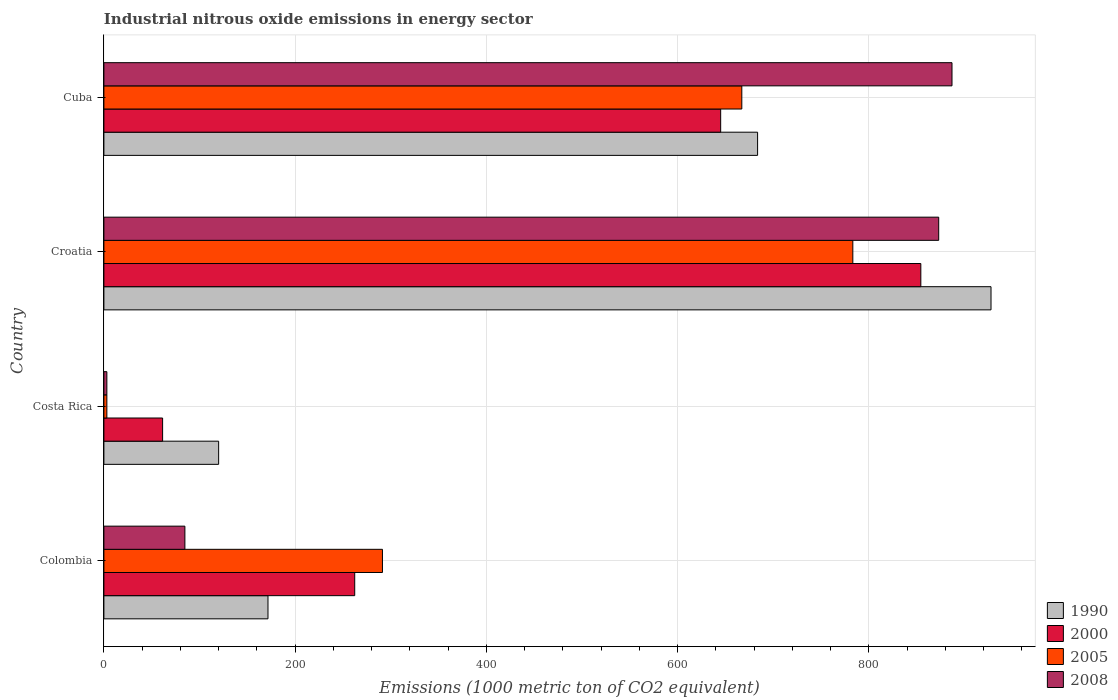How many different coloured bars are there?
Your answer should be very brief. 4. How many groups of bars are there?
Make the answer very short. 4. Are the number of bars on each tick of the Y-axis equal?
Offer a very short reply. Yes. How many bars are there on the 3rd tick from the top?
Provide a succinct answer. 4. How many bars are there on the 4th tick from the bottom?
Your answer should be compact. 4. What is the label of the 1st group of bars from the top?
Your answer should be very brief. Cuba. In how many cases, is the number of bars for a given country not equal to the number of legend labels?
Provide a short and direct response. 0. What is the amount of industrial nitrous oxide emitted in 1990 in Croatia?
Offer a very short reply. 927.7. Across all countries, what is the maximum amount of industrial nitrous oxide emitted in 2005?
Your answer should be compact. 783.2. Across all countries, what is the minimum amount of industrial nitrous oxide emitted in 2000?
Offer a very short reply. 61.4. In which country was the amount of industrial nitrous oxide emitted in 2000 maximum?
Give a very brief answer. Croatia. In which country was the amount of industrial nitrous oxide emitted in 1990 minimum?
Your answer should be very brief. Costa Rica. What is the total amount of industrial nitrous oxide emitted in 2005 in the graph?
Provide a short and direct response. 1744.7. What is the difference between the amount of industrial nitrous oxide emitted in 2008 in Croatia and that in Cuba?
Provide a succinct answer. -13.9. What is the difference between the amount of industrial nitrous oxide emitted in 2005 in Colombia and the amount of industrial nitrous oxide emitted in 2000 in Costa Rica?
Offer a terse response. 229.9. What is the average amount of industrial nitrous oxide emitted in 1990 per country?
Offer a terse response. 475.73. What is the difference between the amount of industrial nitrous oxide emitted in 2000 and amount of industrial nitrous oxide emitted in 2008 in Cuba?
Your answer should be compact. -241.9. In how many countries, is the amount of industrial nitrous oxide emitted in 2005 greater than 800 1000 metric ton?
Keep it short and to the point. 0. What is the ratio of the amount of industrial nitrous oxide emitted in 2000 in Croatia to that in Cuba?
Make the answer very short. 1.32. What is the difference between the highest and the second highest amount of industrial nitrous oxide emitted in 1990?
Offer a very short reply. 244.1. What is the difference between the highest and the lowest amount of industrial nitrous oxide emitted in 2000?
Provide a succinct answer. 792.9. Is the sum of the amount of industrial nitrous oxide emitted in 1990 in Colombia and Croatia greater than the maximum amount of industrial nitrous oxide emitted in 2008 across all countries?
Offer a terse response. Yes. How many bars are there?
Make the answer very short. 16. How many countries are there in the graph?
Keep it short and to the point. 4. Where does the legend appear in the graph?
Offer a terse response. Bottom right. How are the legend labels stacked?
Provide a succinct answer. Vertical. What is the title of the graph?
Your response must be concise. Industrial nitrous oxide emissions in energy sector. What is the label or title of the X-axis?
Your response must be concise. Emissions (1000 metric ton of CO2 equivalent). What is the label or title of the Y-axis?
Offer a terse response. Country. What is the Emissions (1000 metric ton of CO2 equivalent) of 1990 in Colombia?
Ensure brevity in your answer.  171.6. What is the Emissions (1000 metric ton of CO2 equivalent) of 2000 in Colombia?
Offer a very short reply. 262.3. What is the Emissions (1000 metric ton of CO2 equivalent) of 2005 in Colombia?
Make the answer very short. 291.3. What is the Emissions (1000 metric ton of CO2 equivalent) of 2008 in Colombia?
Give a very brief answer. 84.7. What is the Emissions (1000 metric ton of CO2 equivalent) of 1990 in Costa Rica?
Ensure brevity in your answer.  120. What is the Emissions (1000 metric ton of CO2 equivalent) in 2000 in Costa Rica?
Keep it short and to the point. 61.4. What is the Emissions (1000 metric ton of CO2 equivalent) of 2005 in Costa Rica?
Offer a terse response. 3.1. What is the Emissions (1000 metric ton of CO2 equivalent) in 2008 in Costa Rica?
Your answer should be very brief. 3.1. What is the Emissions (1000 metric ton of CO2 equivalent) in 1990 in Croatia?
Offer a terse response. 927.7. What is the Emissions (1000 metric ton of CO2 equivalent) of 2000 in Croatia?
Your response must be concise. 854.3. What is the Emissions (1000 metric ton of CO2 equivalent) of 2005 in Croatia?
Offer a very short reply. 783.2. What is the Emissions (1000 metric ton of CO2 equivalent) in 2008 in Croatia?
Make the answer very short. 873. What is the Emissions (1000 metric ton of CO2 equivalent) in 1990 in Cuba?
Provide a short and direct response. 683.6. What is the Emissions (1000 metric ton of CO2 equivalent) of 2000 in Cuba?
Ensure brevity in your answer.  645. What is the Emissions (1000 metric ton of CO2 equivalent) of 2005 in Cuba?
Make the answer very short. 667.1. What is the Emissions (1000 metric ton of CO2 equivalent) of 2008 in Cuba?
Keep it short and to the point. 886.9. Across all countries, what is the maximum Emissions (1000 metric ton of CO2 equivalent) of 1990?
Make the answer very short. 927.7. Across all countries, what is the maximum Emissions (1000 metric ton of CO2 equivalent) in 2000?
Ensure brevity in your answer.  854.3. Across all countries, what is the maximum Emissions (1000 metric ton of CO2 equivalent) in 2005?
Give a very brief answer. 783.2. Across all countries, what is the maximum Emissions (1000 metric ton of CO2 equivalent) of 2008?
Give a very brief answer. 886.9. Across all countries, what is the minimum Emissions (1000 metric ton of CO2 equivalent) of 1990?
Your response must be concise. 120. Across all countries, what is the minimum Emissions (1000 metric ton of CO2 equivalent) of 2000?
Provide a short and direct response. 61.4. Across all countries, what is the minimum Emissions (1000 metric ton of CO2 equivalent) of 2005?
Provide a succinct answer. 3.1. Across all countries, what is the minimum Emissions (1000 metric ton of CO2 equivalent) in 2008?
Your response must be concise. 3.1. What is the total Emissions (1000 metric ton of CO2 equivalent) in 1990 in the graph?
Offer a terse response. 1902.9. What is the total Emissions (1000 metric ton of CO2 equivalent) in 2000 in the graph?
Keep it short and to the point. 1823. What is the total Emissions (1000 metric ton of CO2 equivalent) in 2005 in the graph?
Your answer should be very brief. 1744.7. What is the total Emissions (1000 metric ton of CO2 equivalent) in 2008 in the graph?
Give a very brief answer. 1847.7. What is the difference between the Emissions (1000 metric ton of CO2 equivalent) in 1990 in Colombia and that in Costa Rica?
Make the answer very short. 51.6. What is the difference between the Emissions (1000 metric ton of CO2 equivalent) of 2000 in Colombia and that in Costa Rica?
Give a very brief answer. 200.9. What is the difference between the Emissions (1000 metric ton of CO2 equivalent) of 2005 in Colombia and that in Costa Rica?
Give a very brief answer. 288.2. What is the difference between the Emissions (1000 metric ton of CO2 equivalent) in 2008 in Colombia and that in Costa Rica?
Offer a terse response. 81.6. What is the difference between the Emissions (1000 metric ton of CO2 equivalent) in 1990 in Colombia and that in Croatia?
Offer a very short reply. -756.1. What is the difference between the Emissions (1000 metric ton of CO2 equivalent) in 2000 in Colombia and that in Croatia?
Offer a terse response. -592. What is the difference between the Emissions (1000 metric ton of CO2 equivalent) in 2005 in Colombia and that in Croatia?
Your answer should be compact. -491.9. What is the difference between the Emissions (1000 metric ton of CO2 equivalent) of 2008 in Colombia and that in Croatia?
Keep it short and to the point. -788.3. What is the difference between the Emissions (1000 metric ton of CO2 equivalent) in 1990 in Colombia and that in Cuba?
Keep it short and to the point. -512. What is the difference between the Emissions (1000 metric ton of CO2 equivalent) of 2000 in Colombia and that in Cuba?
Offer a terse response. -382.7. What is the difference between the Emissions (1000 metric ton of CO2 equivalent) of 2005 in Colombia and that in Cuba?
Ensure brevity in your answer.  -375.8. What is the difference between the Emissions (1000 metric ton of CO2 equivalent) of 2008 in Colombia and that in Cuba?
Ensure brevity in your answer.  -802.2. What is the difference between the Emissions (1000 metric ton of CO2 equivalent) in 1990 in Costa Rica and that in Croatia?
Your response must be concise. -807.7. What is the difference between the Emissions (1000 metric ton of CO2 equivalent) in 2000 in Costa Rica and that in Croatia?
Provide a short and direct response. -792.9. What is the difference between the Emissions (1000 metric ton of CO2 equivalent) in 2005 in Costa Rica and that in Croatia?
Provide a short and direct response. -780.1. What is the difference between the Emissions (1000 metric ton of CO2 equivalent) in 2008 in Costa Rica and that in Croatia?
Your answer should be compact. -869.9. What is the difference between the Emissions (1000 metric ton of CO2 equivalent) of 1990 in Costa Rica and that in Cuba?
Offer a very short reply. -563.6. What is the difference between the Emissions (1000 metric ton of CO2 equivalent) in 2000 in Costa Rica and that in Cuba?
Your answer should be compact. -583.6. What is the difference between the Emissions (1000 metric ton of CO2 equivalent) of 2005 in Costa Rica and that in Cuba?
Provide a short and direct response. -664. What is the difference between the Emissions (1000 metric ton of CO2 equivalent) of 2008 in Costa Rica and that in Cuba?
Provide a succinct answer. -883.8. What is the difference between the Emissions (1000 metric ton of CO2 equivalent) of 1990 in Croatia and that in Cuba?
Keep it short and to the point. 244.1. What is the difference between the Emissions (1000 metric ton of CO2 equivalent) in 2000 in Croatia and that in Cuba?
Your response must be concise. 209.3. What is the difference between the Emissions (1000 metric ton of CO2 equivalent) of 2005 in Croatia and that in Cuba?
Keep it short and to the point. 116.1. What is the difference between the Emissions (1000 metric ton of CO2 equivalent) in 1990 in Colombia and the Emissions (1000 metric ton of CO2 equivalent) in 2000 in Costa Rica?
Keep it short and to the point. 110.2. What is the difference between the Emissions (1000 metric ton of CO2 equivalent) in 1990 in Colombia and the Emissions (1000 metric ton of CO2 equivalent) in 2005 in Costa Rica?
Offer a very short reply. 168.5. What is the difference between the Emissions (1000 metric ton of CO2 equivalent) in 1990 in Colombia and the Emissions (1000 metric ton of CO2 equivalent) in 2008 in Costa Rica?
Your answer should be very brief. 168.5. What is the difference between the Emissions (1000 metric ton of CO2 equivalent) in 2000 in Colombia and the Emissions (1000 metric ton of CO2 equivalent) in 2005 in Costa Rica?
Make the answer very short. 259.2. What is the difference between the Emissions (1000 metric ton of CO2 equivalent) of 2000 in Colombia and the Emissions (1000 metric ton of CO2 equivalent) of 2008 in Costa Rica?
Your answer should be compact. 259.2. What is the difference between the Emissions (1000 metric ton of CO2 equivalent) of 2005 in Colombia and the Emissions (1000 metric ton of CO2 equivalent) of 2008 in Costa Rica?
Make the answer very short. 288.2. What is the difference between the Emissions (1000 metric ton of CO2 equivalent) of 1990 in Colombia and the Emissions (1000 metric ton of CO2 equivalent) of 2000 in Croatia?
Give a very brief answer. -682.7. What is the difference between the Emissions (1000 metric ton of CO2 equivalent) in 1990 in Colombia and the Emissions (1000 metric ton of CO2 equivalent) in 2005 in Croatia?
Provide a succinct answer. -611.6. What is the difference between the Emissions (1000 metric ton of CO2 equivalent) of 1990 in Colombia and the Emissions (1000 metric ton of CO2 equivalent) of 2008 in Croatia?
Your answer should be compact. -701.4. What is the difference between the Emissions (1000 metric ton of CO2 equivalent) in 2000 in Colombia and the Emissions (1000 metric ton of CO2 equivalent) in 2005 in Croatia?
Give a very brief answer. -520.9. What is the difference between the Emissions (1000 metric ton of CO2 equivalent) in 2000 in Colombia and the Emissions (1000 metric ton of CO2 equivalent) in 2008 in Croatia?
Your answer should be compact. -610.7. What is the difference between the Emissions (1000 metric ton of CO2 equivalent) in 2005 in Colombia and the Emissions (1000 metric ton of CO2 equivalent) in 2008 in Croatia?
Your response must be concise. -581.7. What is the difference between the Emissions (1000 metric ton of CO2 equivalent) of 1990 in Colombia and the Emissions (1000 metric ton of CO2 equivalent) of 2000 in Cuba?
Make the answer very short. -473.4. What is the difference between the Emissions (1000 metric ton of CO2 equivalent) in 1990 in Colombia and the Emissions (1000 metric ton of CO2 equivalent) in 2005 in Cuba?
Your answer should be compact. -495.5. What is the difference between the Emissions (1000 metric ton of CO2 equivalent) in 1990 in Colombia and the Emissions (1000 metric ton of CO2 equivalent) in 2008 in Cuba?
Provide a short and direct response. -715.3. What is the difference between the Emissions (1000 metric ton of CO2 equivalent) of 2000 in Colombia and the Emissions (1000 metric ton of CO2 equivalent) of 2005 in Cuba?
Provide a succinct answer. -404.8. What is the difference between the Emissions (1000 metric ton of CO2 equivalent) in 2000 in Colombia and the Emissions (1000 metric ton of CO2 equivalent) in 2008 in Cuba?
Ensure brevity in your answer.  -624.6. What is the difference between the Emissions (1000 metric ton of CO2 equivalent) in 2005 in Colombia and the Emissions (1000 metric ton of CO2 equivalent) in 2008 in Cuba?
Your response must be concise. -595.6. What is the difference between the Emissions (1000 metric ton of CO2 equivalent) in 1990 in Costa Rica and the Emissions (1000 metric ton of CO2 equivalent) in 2000 in Croatia?
Keep it short and to the point. -734.3. What is the difference between the Emissions (1000 metric ton of CO2 equivalent) in 1990 in Costa Rica and the Emissions (1000 metric ton of CO2 equivalent) in 2005 in Croatia?
Keep it short and to the point. -663.2. What is the difference between the Emissions (1000 metric ton of CO2 equivalent) of 1990 in Costa Rica and the Emissions (1000 metric ton of CO2 equivalent) of 2008 in Croatia?
Your answer should be very brief. -753. What is the difference between the Emissions (1000 metric ton of CO2 equivalent) of 2000 in Costa Rica and the Emissions (1000 metric ton of CO2 equivalent) of 2005 in Croatia?
Your answer should be very brief. -721.8. What is the difference between the Emissions (1000 metric ton of CO2 equivalent) of 2000 in Costa Rica and the Emissions (1000 metric ton of CO2 equivalent) of 2008 in Croatia?
Give a very brief answer. -811.6. What is the difference between the Emissions (1000 metric ton of CO2 equivalent) in 2005 in Costa Rica and the Emissions (1000 metric ton of CO2 equivalent) in 2008 in Croatia?
Offer a terse response. -869.9. What is the difference between the Emissions (1000 metric ton of CO2 equivalent) of 1990 in Costa Rica and the Emissions (1000 metric ton of CO2 equivalent) of 2000 in Cuba?
Keep it short and to the point. -525. What is the difference between the Emissions (1000 metric ton of CO2 equivalent) in 1990 in Costa Rica and the Emissions (1000 metric ton of CO2 equivalent) in 2005 in Cuba?
Offer a terse response. -547.1. What is the difference between the Emissions (1000 metric ton of CO2 equivalent) of 1990 in Costa Rica and the Emissions (1000 metric ton of CO2 equivalent) of 2008 in Cuba?
Your answer should be compact. -766.9. What is the difference between the Emissions (1000 metric ton of CO2 equivalent) in 2000 in Costa Rica and the Emissions (1000 metric ton of CO2 equivalent) in 2005 in Cuba?
Provide a short and direct response. -605.7. What is the difference between the Emissions (1000 metric ton of CO2 equivalent) in 2000 in Costa Rica and the Emissions (1000 metric ton of CO2 equivalent) in 2008 in Cuba?
Your answer should be very brief. -825.5. What is the difference between the Emissions (1000 metric ton of CO2 equivalent) in 2005 in Costa Rica and the Emissions (1000 metric ton of CO2 equivalent) in 2008 in Cuba?
Provide a short and direct response. -883.8. What is the difference between the Emissions (1000 metric ton of CO2 equivalent) in 1990 in Croatia and the Emissions (1000 metric ton of CO2 equivalent) in 2000 in Cuba?
Your answer should be very brief. 282.7. What is the difference between the Emissions (1000 metric ton of CO2 equivalent) in 1990 in Croatia and the Emissions (1000 metric ton of CO2 equivalent) in 2005 in Cuba?
Give a very brief answer. 260.6. What is the difference between the Emissions (1000 metric ton of CO2 equivalent) of 1990 in Croatia and the Emissions (1000 metric ton of CO2 equivalent) of 2008 in Cuba?
Give a very brief answer. 40.8. What is the difference between the Emissions (1000 metric ton of CO2 equivalent) in 2000 in Croatia and the Emissions (1000 metric ton of CO2 equivalent) in 2005 in Cuba?
Ensure brevity in your answer.  187.2. What is the difference between the Emissions (1000 metric ton of CO2 equivalent) in 2000 in Croatia and the Emissions (1000 metric ton of CO2 equivalent) in 2008 in Cuba?
Provide a short and direct response. -32.6. What is the difference between the Emissions (1000 metric ton of CO2 equivalent) in 2005 in Croatia and the Emissions (1000 metric ton of CO2 equivalent) in 2008 in Cuba?
Provide a succinct answer. -103.7. What is the average Emissions (1000 metric ton of CO2 equivalent) of 1990 per country?
Offer a terse response. 475.73. What is the average Emissions (1000 metric ton of CO2 equivalent) in 2000 per country?
Your answer should be very brief. 455.75. What is the average Emissions (1000 metric ton of CO2 equivalent) in 2005 per country?
Offer a terse response. 436.18. What is the average Emissions (1000 metric ton of CO2 equivalent) of 2008 per country?
Provide a succinct answer. 461.93. What is the difference between the Emissions (1000 metric ton of CO2 equivalent) in 1990 and Emissions (1000 metric ton of CO2 equivalent) in 2000 in Colombia?
Provide a short and direct response. -90.7. What is the difference between the Emissions (1000 metric ton of CO2 equivalent) in 1990 and Emissions (1000 metric ton of CO2 equivalent) in 2005 in Colombia?
Your answer should be compact. -119.7. What is the difference between the Emissions (1000 metric ton of CO2 equivalent) in 1990 and Emissions (1000 metric ton of CO2 equivalent) in 2008 in Colombia?
Your answer should be compact. 86.9. What is the difference between the Emissions (1000 metric ton of CO2 equivalent) of 2000 and Emissions (1000 metric ton of CO2 equivalent) of 2008 in Colombia?
Your answer should be compact. 177.6. What is the difference between the Emissions (1000 metric ton of CO2 equivalent) of 2005 and Emissions (1000 metric ton of CO2 equivalent) of 2008 in Colombia?
Your answer should be compact. 206.6. What is the difference between the Emissions (1000 metric ton of CO2 equivalent) of 1990 and Emissions (1000 metric ton of CO2 equivalent) of 2000 in Costa Rica?
Offer a terse response. 58.6. What is the difference between the Emissions (1000 metric ton of CO2 equivalent) in 1990 and Emissions (1000 metric ton of CO2 equivalent) in 2005 in Costa Rica?
Keep it short and to the point. 116.9. What is the difference between the Emissions (1000 metric ton of CO2 equivalent) in 1990 and Emissions (1000 metric ton of CO2 equivalent) in 2008 in Costa Rica?
Provide a succinct answer. 116.9. What is the difference between the Emissions (1000 metric ton of CO2 equivalent) of 2000 and Emissions (1000 metric ton of CO2 equivalent) of 2005 in Costa Rica?
Provide a succinct answer. 58.3. What is the difference between the Emissions (1000 metric ton of CO2 equivalent) in 2000 and Emissions (1000 metric ton of CO2 equivalent) in 2008 in Costa Rica?
Offer a very short reply. 58.3. What is the difference between the Emissions (1000 metric ton of CO2 equivalent) in 2005 and Emissions (1000 metric ton of CO2 equivalent) in 2008 in Costa Rica?
Your response must be concise. 0. What is the difference between the Emissions (1000 metric ton of CO2 equivalent) of 1990 and Emissions (1000 metric ton of CO2 equivalent) of 2000 in Croatia?
Give a very brief answer. 73.4. What is the difference between the Emissions (1000 metric ton of CO2 equivalent) of 1990 and Emissions (1000 metric ton of CO2 equivalent) of 2005 in Croatia?
Provide a succinct answer. 144.5. What is the difference between the Emissions (1000 metric ton of CO2 equivalent) in 1990 and Emissions (1000 metric ton of CO2 equivalent) in 2008 in Croatia?
Provide a short and direct response. 54.7. What is the difference between the Emissions (1000 metric ton of CO2 equivalent) of 2000 and Emissions (1000 metric ton of CO2 equivalent) of 2005 in Croatia?
Offer a terse response. 71.1. What is the difference between the Emissions (1000 metric ton of CO2 equivalent) of 2000 and Emissions (1000 metric ton of CO2 equivalent) of 2008 in Croatia?
Ensure brevity in your answer.  -18.7. What is the difference between the Emissions (1000 metric ton of CO2 equivalent) in 2005 and Emissions (1000 metric ton of CO2 equivalent) in 2008 in Croatia?
Give a very brief answer. -89.8. What is the difference between the Emissions (1000 metric ton of CO2 equivalent) in 1990 and Emissions (1000 metric ton of CO2 equivalent) in 2000 in Cuba?
Your answer should be very brief. 38.6. What is the difference between the Emissions (1000 metric ton of CO2 equivalent) of 1990 and Emissions (1000 metric ton of CO2 equivalent) of 2008 in Cuba?
Your answer should be very brief. -203.3. What is the difference between the Emissions (1000 metric ton of CO2 equivalent) of 2000 and Emissions (1000 metric ton of CO2 equivalent) of 2005 in Cuba?
Offer a terse response. -22.1. What is the difference between the Emissions (1000 metric ton of CO2 equivalent) in 2000 and Emissions (1000 metric ton of CO2 equivalent) in 2008 in Cuba?
Keep it short and to the point. -241.9. What is the difference between the Emissions (1000 metric ton of CO2 equivalent) of 2005 and Emissions (1000 metric ton of CO2 equivalent) of 2008 in Cuba?
Provide a short and direct response. -219.8. What is the ratio of the Emissions (1000 metric ton of CO2 equivalent) in 1990 in Colombia to that in Costa Rica?
Make the answer very short. 1.43. What is the ratio of the Emissions (1000 metric ton of CO2 equivalent) of 2000 in Colombia to that in Costa Rica?
Ensure brevity in your answer.  4.27. What is the ratio of the Emissions (1000 metric ton of CO2 equivalent) of 2005 in Colombia to that in Costa Rica?
Give a very brief answer. 93.97. What is the ratio of the Emissions (1000 metric ton of CO2 equivalent) of 2008 in Colombia to that in Costa Rica?
Keep it short and to the point. 27.32. What is the ratio of the Emissions (1000 metric ton of CO2 equivalent) of 1990 in Colombia to that in Croatia?
Offer a terse response. 0.18. What is the ratio of the Emissions (1000 metric ton of CO2 equivalent) in 2000 in Colombia to that in Croatia?
Offer a very short reply. 0.31. What is the ratio of the Emissions (1000 metric ton of CO2 equivalent) of 2005 in Colombia to that in Croatia?
Make the answer very short. 0.37. What is the ratio of the Emissions (1000 metric ton of CO2 equivalent) of 2008 in Colombia to that in Croatia?
Make the answer very short. 0.1. What is the ratio of the Emissions (1000 metric ton of CO2 equivalent) in 1990 in Colombia to that in Cuba?
Make the answer very short. 0.25. What is the ratio of the Emissions (1000 metric ton of CO2 equivalent) of 2000 in Colombia to that in Cuba?
Offer a terse response. 0.41. What is the ratio of the Emissions (1000 metric ton of CO2 equivalent) in 2005 in Colombia to that in Cuba?
Your answer should be compact. 0.44. What is the ratio of the Emissions (1000 metric ton of CO2 equivalent) in 2008 in Colombia to that in Cuba?
Offer a terse response. 0.1. What is the ratio of the Emissions (1000 metric ton of CO2 equivalent) of 1990 in Costa Rica to that in Croatia?
Your answer should be very brief. 0.13. What is the ratio of the Emissions (1000 metric ton of CO2 equivalent) in 2000 in Costa Rica to that in Croatia?
Offer a very short reply. 0.07. What is the ratio of the Emissions (1000 metric ton of CO2 equivalent) in 2005 in Costa Rica to that in Croatia?
Your answer should be compact. 0. What is the ratio of the Emissions (1000 metric ton of CO2 equivalent) in 2008 in Costa Rica to that in Croatia?
Offer a very short reply. 0. What is the ratio of the Emissions (1000 metric ton of CO2 equivalent) in 1990 in Costa Rica to that in Cuba?
Make the answer very short. 0.18. What is the ratio of the Emissions (1000 metric ton of CO2 equivalent) of 2000 in Costa Rica to that in Cuba?
Make the answer very short. 0.1. What is the ratio of the Emissions (1000 metric ton of CO2 equivalent) in 2005 in Costa Rica to that in Cuba?
Ensure brevity in your answer.  0. What is the ratio of the Emissions (1000 metric ton of CO2 equivalent) of 2008 in Costa Rica to that in Cuba?
Provide a succinct answer. 0. What is the ratio of the Emissions (1000 metric ton of CO2 equivalent) of 1990 in Croatia to that in Cuba?
Keep it short and to the point. 1.36. What is the ratio of the Emissions (1000 metric ton of CO2 equivalent) in 2000 in Croatia to that in Cuba?
Your response must be concise. 1.32. What is the ratio of the Emissions (1000 metric ton of CO2 equivalent) in 2005 in Croatia to that in Cuba?
Your answer should be very brief. 1.17. What is the ratio of the Emissions (1000 metric ton of CO2 equivalent) in 2008 in Croatia to that in Cuba?
Offer a terse response. 0.98. What is the difference between the highest and the second highest Emissions (1000 metric ton of CO2 equivalent) of 1990?
Offer a very short reply. 244.1. What is the difference between the highest and the second highest Emissions (1000 metric ton of CO2 equivalent) in 2000?
Provide a short and direct response. 209.3. What is the difference between the highest and the second highest Emissions (1000 metric ton of CO2 equivalent) in 2005?
Give a very brief answer. 116.1. What is the difference between the highest and the second highest Emissions (1000 metric ton of CO2 equivalent) in 2008?
Provide a short and direct response. 13.9. What is the difference between the highest and the lowest Emissions (1000 metric ton of CO2 equivalent) in 1990?
Provide a short and direct response. 807.7. What is the difference between the highest and the lowest Emissions (1000 metric ton of CO2 equivalent) in 2000?
Your response must be concise. 792.9. What is the difference between the highest and the lowest Emissions (1000 metric ton of CO2 equivalent) in 2005?
Offer a very short reply. 780.1. What is the difference between the highest and the lowest Emissions (1000 metric ton of CO2 equivalent) in 2008?
Offer a terse response. 883.8. 